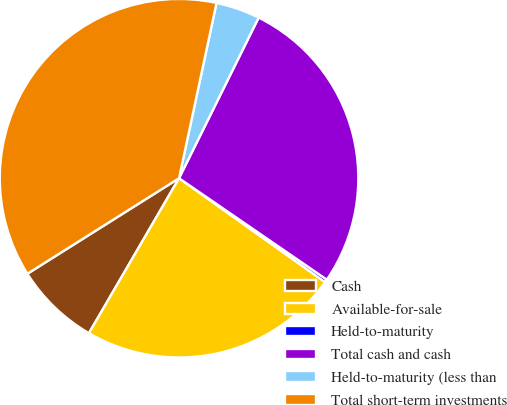<chart> <loc_0><loc_0><loc_500><loc_500><pie_chart><fcel>Cash<fcel>Available-for-sale<fcel>Held-to-maturity<fcel>Total cash and cash<fcel>Held-to-maturity (less than<fcel>Total short-term investments<nl><fcel>7.67%<fcel>23.54%<fcel>0.27%<fcel>27.25%<fcel>3.97%<fcel>37.3%<nl></chart> 